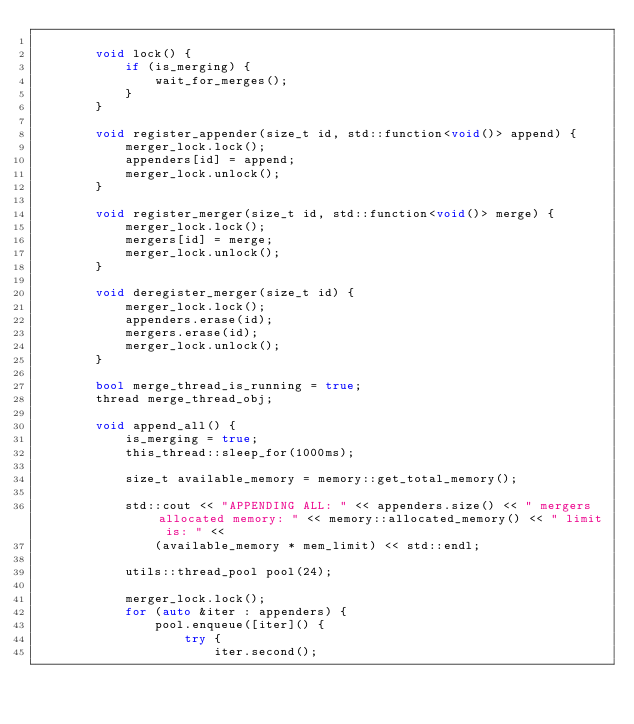Convert code to text. <code><loc_0><loc_0><loc_500><loc_500><_C++_>
		void lock() {
			if (is_merging) {
				wait_for_merges();
			}
		}

		void register_appender(size_t id, std::function<void()> append) {
			merger_lock.lock();
			appenders[id] = append;
			merger_lock.unlock();
		}

		void register_merger(size_t id, std::function<void()> merge) {
			merger_lock.lock();
			mergers[id] = merge;
			merger_lock.unlock();
		}

		void deregister_merger(size_t id) {
			merger_lock.lock();
			appenders.erase(id);
			mergers.erase(id);
			merger_lock.unlock();
		}

		bool merge_thread_is_running = true;
		thread merge_thread_obj;

		void append_all() {
			is_merging = true;
			this_thread::sleep_for(1000ms);

			size_t available_memory = memory::get_total_memory();

			std::cout << "APPENDING ALL: " << appenders.size() << " mergers allocated memory: " << memory::allocated_memory() << " limit is: " <<
				(available_memory * mem_limit) << std::endl;
			
			utils::thread_pool pool(24);

			merger_lock.lock();
			for (auto &iter : appenders) {
				pool.enqueue([iter]() {
					try {
						iter.second();</code> 